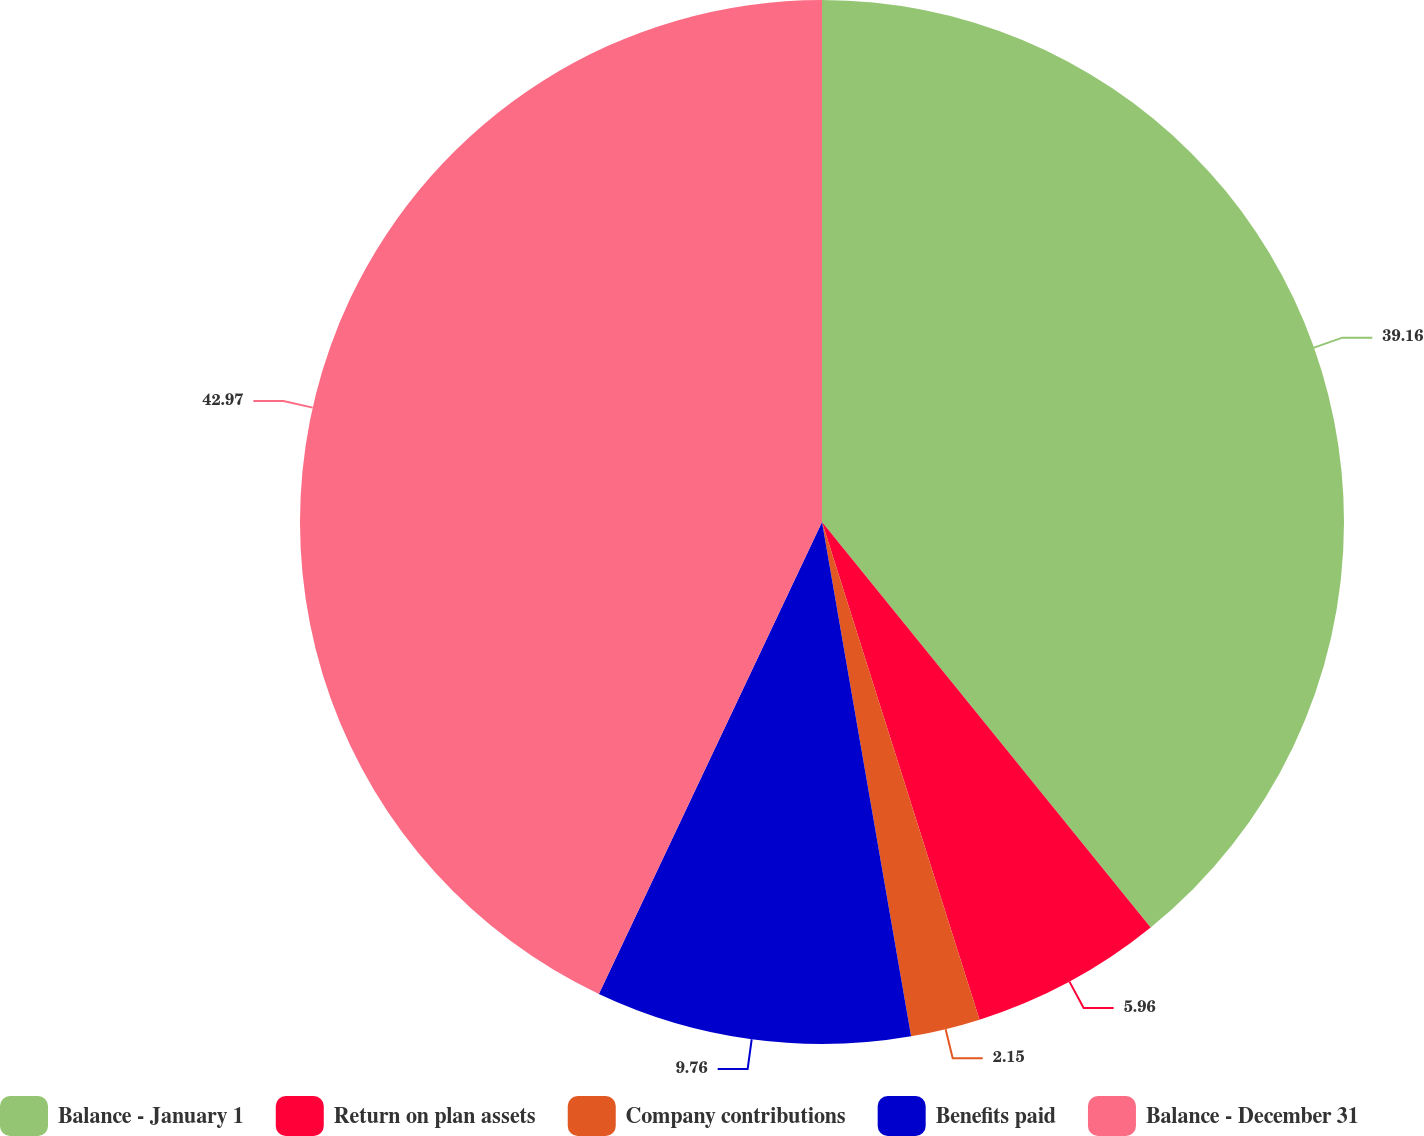<chart> <loc_0><loc_0><loc_500><loc_500><pie_chart><fcel>Balance - January 1<fcel>Return on plan assets<fcel>Company contributions<fcel>Benefits paid<fcel>Balance - December 31<nl><fcel>39.16%<fcel>5.96%<fcel>2.15%<fcel>9.76%<fcel>42.97%<nl></chart> 